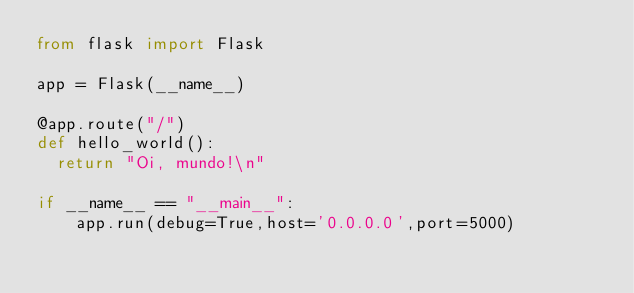Convert code to text. <code><loc_0><loc_0><loc_500><loc_500><_Python_>from flask import Flask

app = Flask(__name__)

@app.route("/")
def hello_world():
  return "Oi, mundo!\n"

if __name__ == "__main__":
    app.run(debug=True,host='0.0.0.0',port=5000)
</code> 